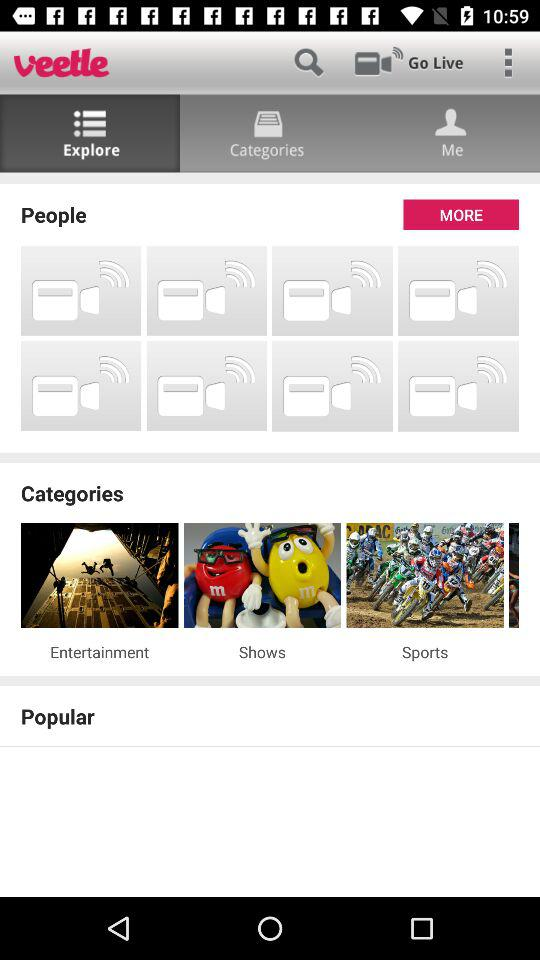Which tab is currently selected? The currently selected tab is "Explore". 